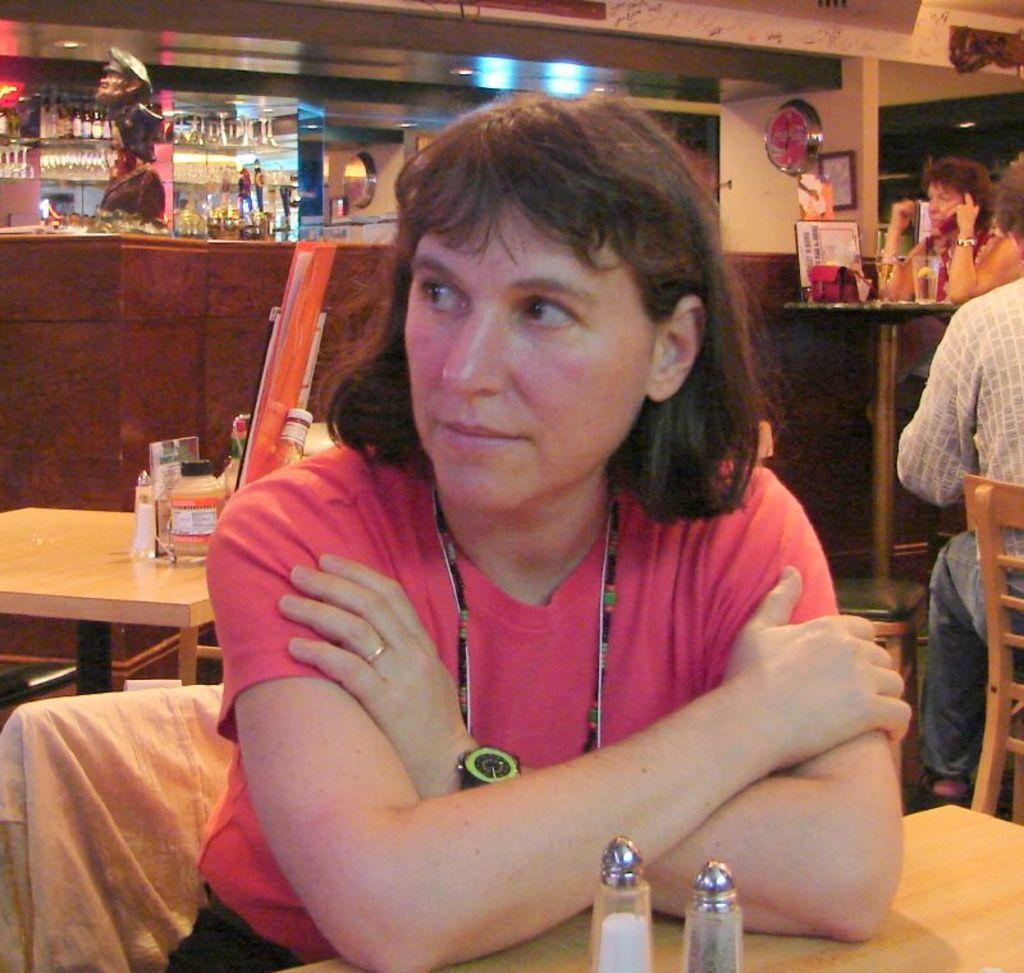Could you give a brief overview of what you see in this image? As we can see in the image there is a wall, photo frame, fan, shelves filled with bottles, doll, few people sitting on chairs and there are tables. On table there is a handbag, glass, mug and bottles. 